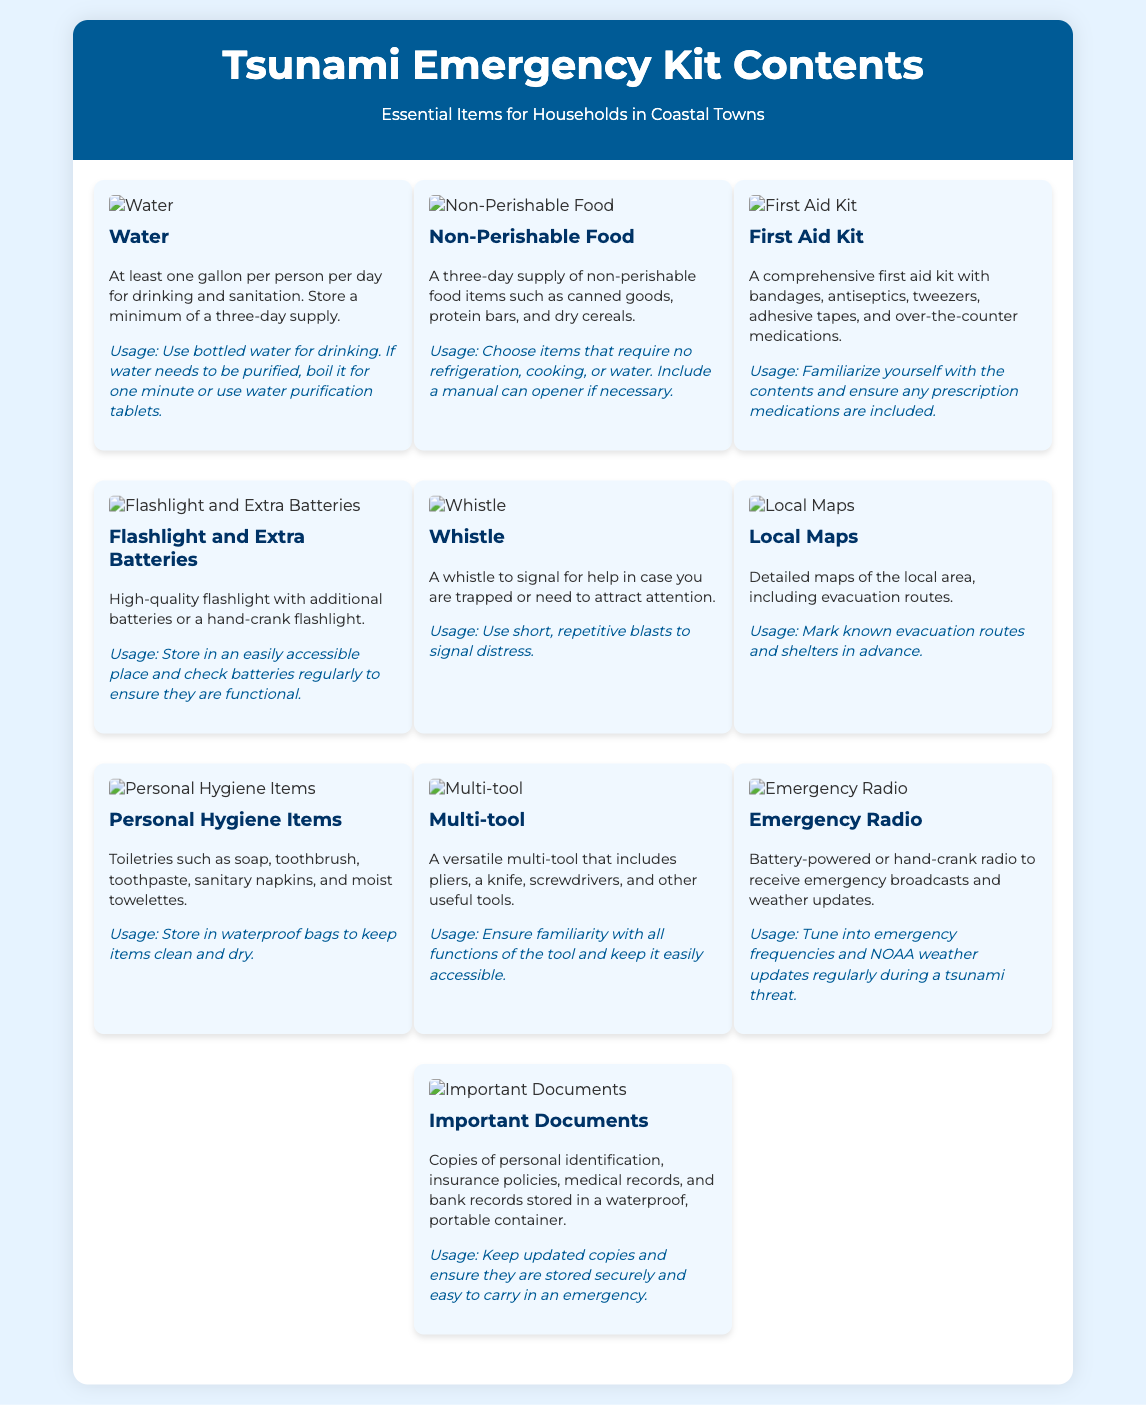What is the total amount of water recommended per person? The document specifies at least one gallon of water per person per day, with a minimum of a three-day supply recommended.
Answer: One gallon What type of food is included in the emergency kit? The emergency kit recommends a three-day supply of non-perishable food items such as canned goods, protein bars, and dry cereals.
Answer: Non-Perishable Food What is a recommended use for the emergency radio? The emergency radio should be tuned into emergency frequencies and NOAA weather updates during a tsunami threat.
Answer: Tune into emergency frequencies What personal hygiene items are suggested for the kit? The document lists toiletries such as soap, toothbrush, toothpaste, sanitary napkins, and moist towelettes.
Answer: Personal Hygiene Items How many batteries should you have for the flashlight? The document recommends having extra batteries for the flashlight.
Answer: Extra Batteries What is the purpose of the whistle in the emergency kit? The whistle is used to signal for help in case you are trapped or need to attract attention.
Answer: Signal for help What should you do with important documents? Important documents should be stored in a waterproof, portable container and kept easy to carry in an emergency.
Answer: Waterproof, portable container Which item is recommended for sanitation in the kit? The document suggests including at least one gallon of water per person per day for sanitation.
Answer: Water What is included in the first aid kit? The first aid kit should contain bandages, antiseptics, tweezers, adhesive tapes, and over-the-counter medications.
Answer: Bandages, antiseptics, tweezers, adhesive tapes, medications 